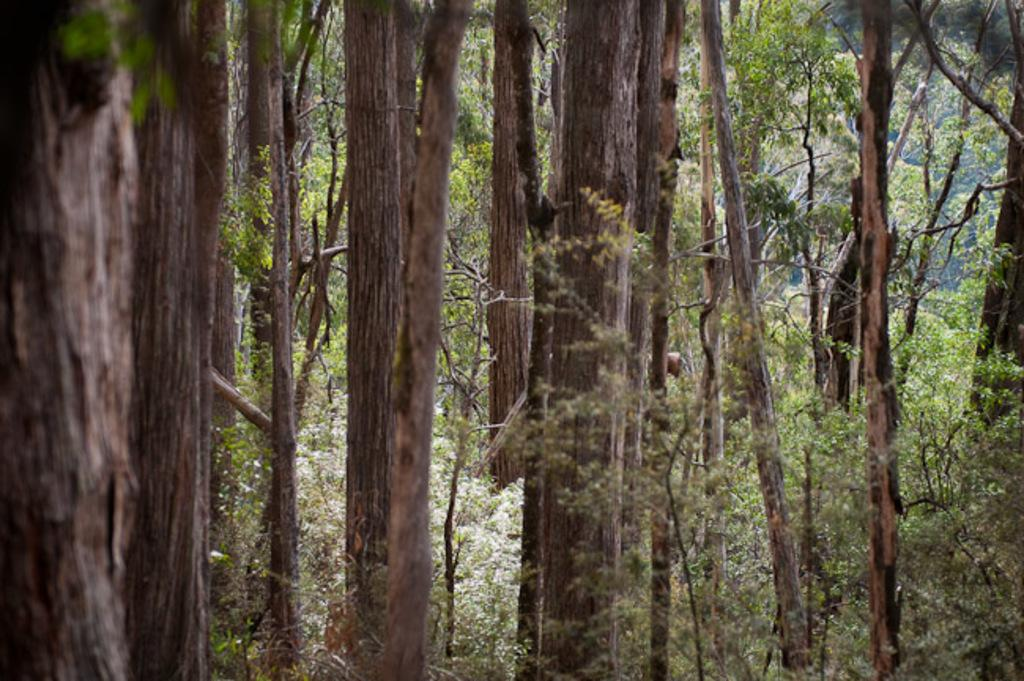What type of vegetation can be seen in the image? There are trees and plants in the image. Can you describe the trees in the image? The facts provided do not give specific details about the trees, but we can confirm that trees are present. What other type of vegetation is in the image besides trees? There are plants in the image. What type of government is depicted in the image? There is no government depicted in the image; it features trees and plants. What kind of punishment is being carried out in the image? There is no punishment being carried out in the image; it features trees and plants. 